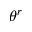Convert formula to latex. <formula><loc_0><loc_0><loc_500><loc_500>\theta ^ { r }</formula> 